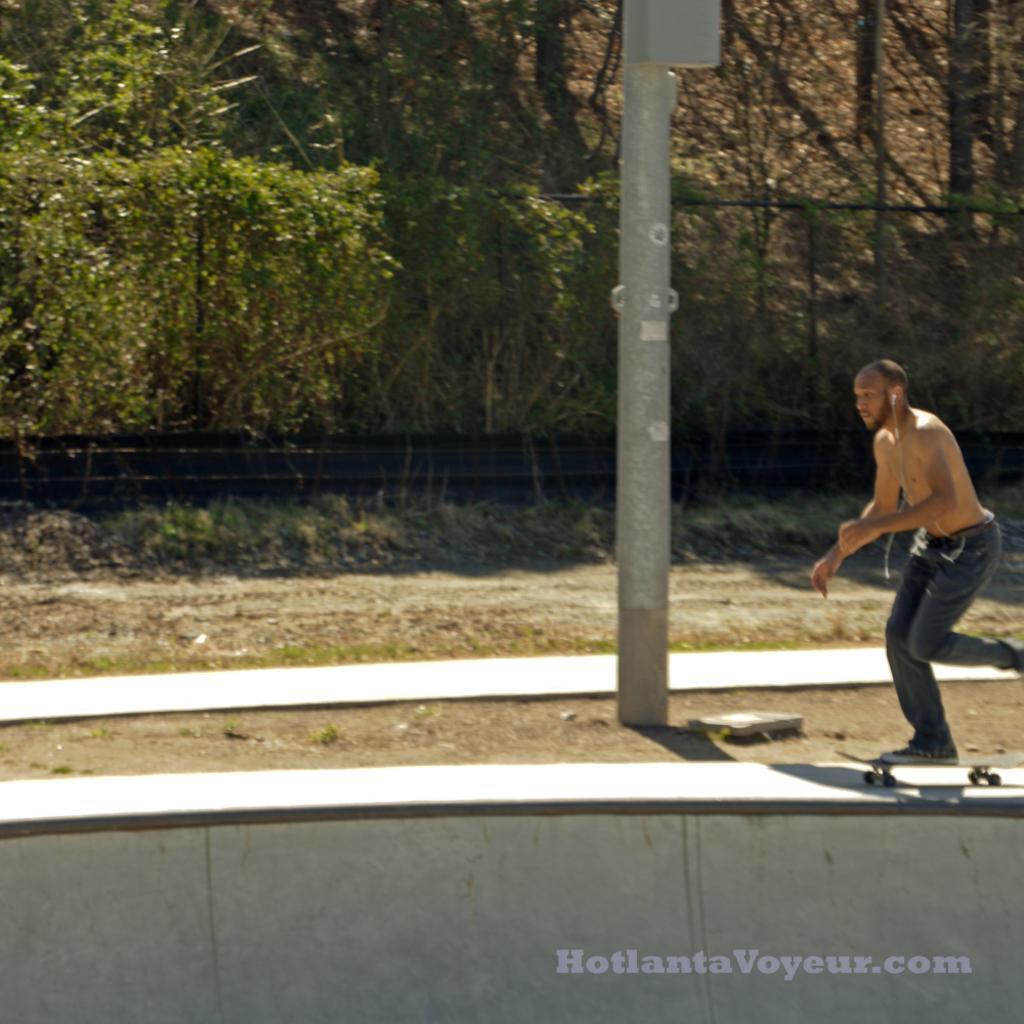In one or two sentences, can you explain what this image depicts? In this image I can see a person skating. I can see a pole. In the background, I can see the fence and the trees. 